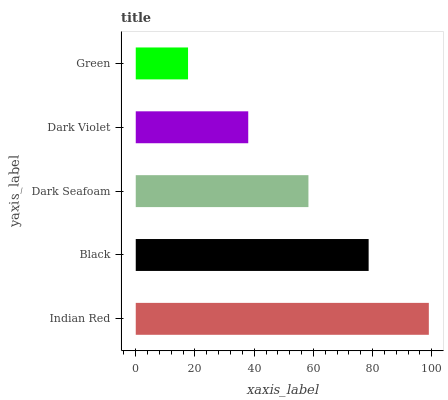Is Green the minimum?
Answer yes or no. Yes. Is Indian Red the maximum?
Answer yes or no. Yes. Is Black the minimum?
Answer yes or no. No. Is Black the maximum?
Answer yes or no. No. Is Indian Red greater than Black?
Answer yes or no. Yes. Is Black less than Indian Red?
Answer yes or no. Yes. Is Black greater than Indian Red?
Answer yes or no. No. Is Indian Red less than Black?
Answer yes or no. No. Is Dark Seafoam the high median?
Answer yes or no. Yes. Is Dark Seafoam the low median?
Answer yes or no. Yes. Is Black the high median?
Answer yes or no. No. Is Green the low median?
Answer yes or no. No. 